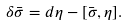Convert formula to latex. <formula><loc_0><loc_0><loc_500><loc_500>\delta \bar { \sigma } = d \eta - [ \bar { \sigma } , \eta ] .</formula> 